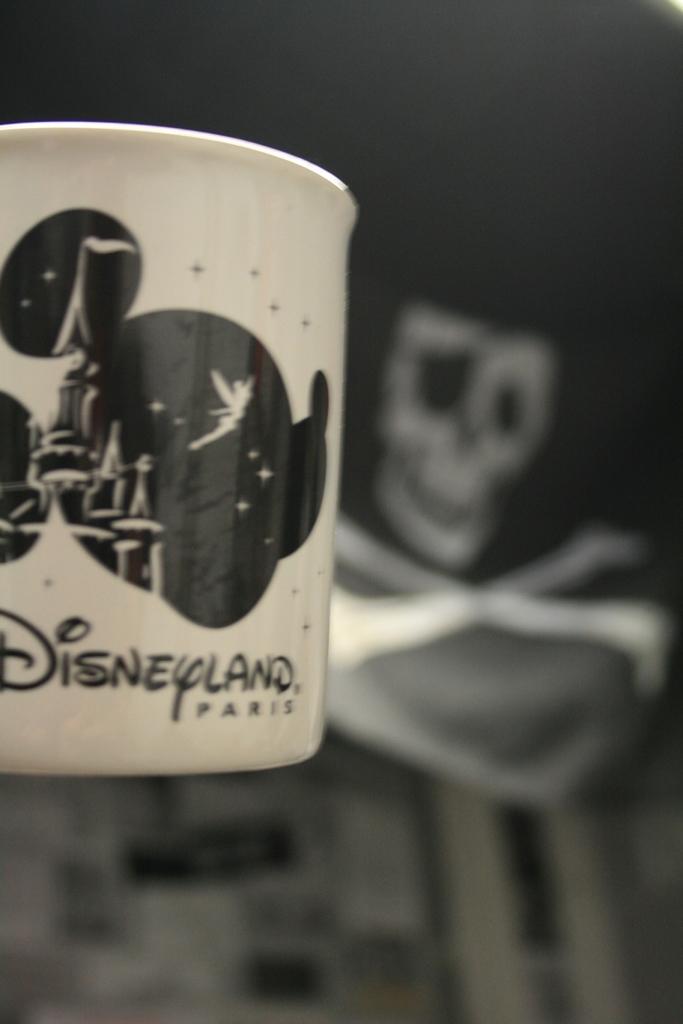Where is this cup from?
Give a very brief answer. Disneyland paris. What city is disneyland in?
Ensure brevity in your answer.  Paris. 